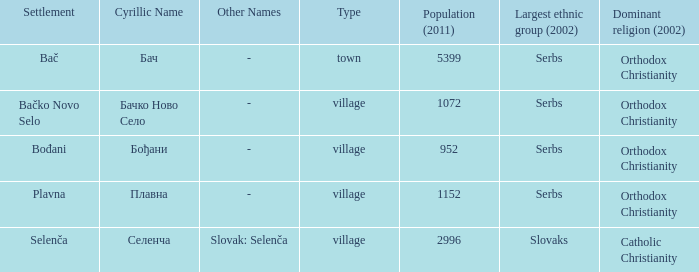What is the second way of writting плавна. Plavna. 